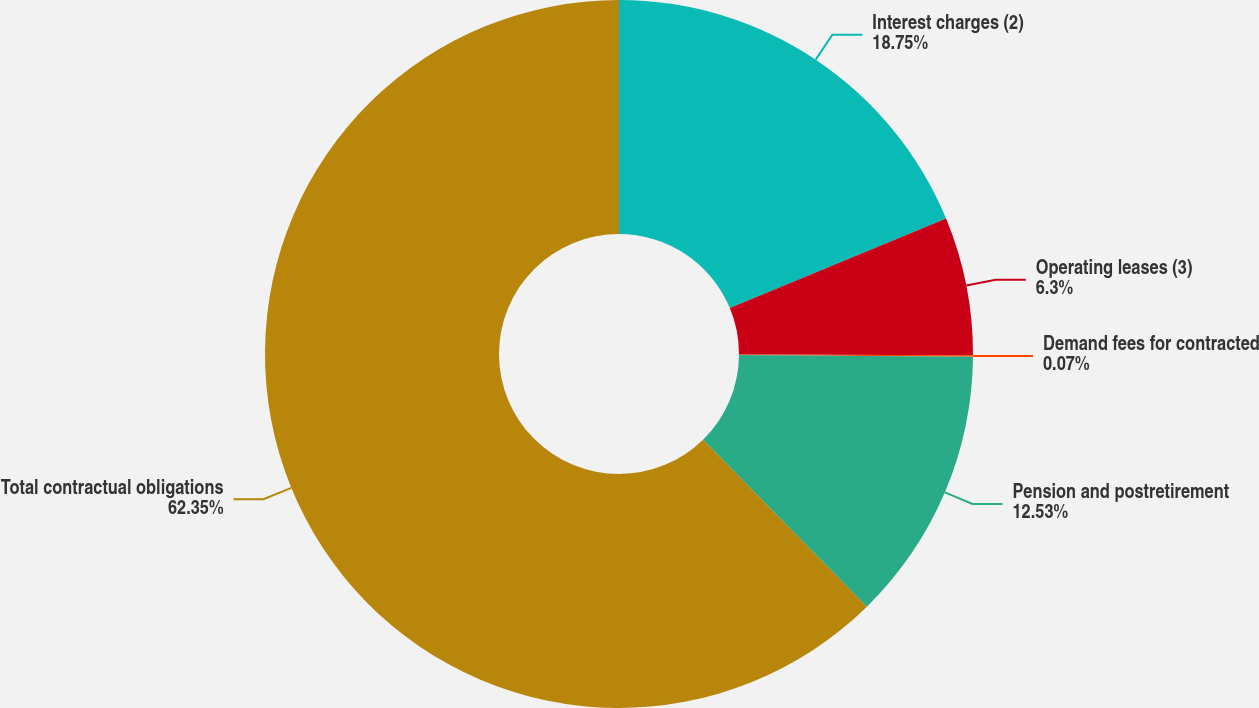Convert chart to OTSL. <chart><loc_0><loc_0><loc_500><loc_500><pie_chart><fcel>Interest charges (2)<fcel>Operating leases (3)<fcel>Demand fees for contracted<fcel>Pension and postretirement<fcel>Total contractual obligations<nl><fcel>18.75%<fcel>6.3%<fcel>0.07%<fcel>12.53%<fcel>62.34%<nl></chart> 